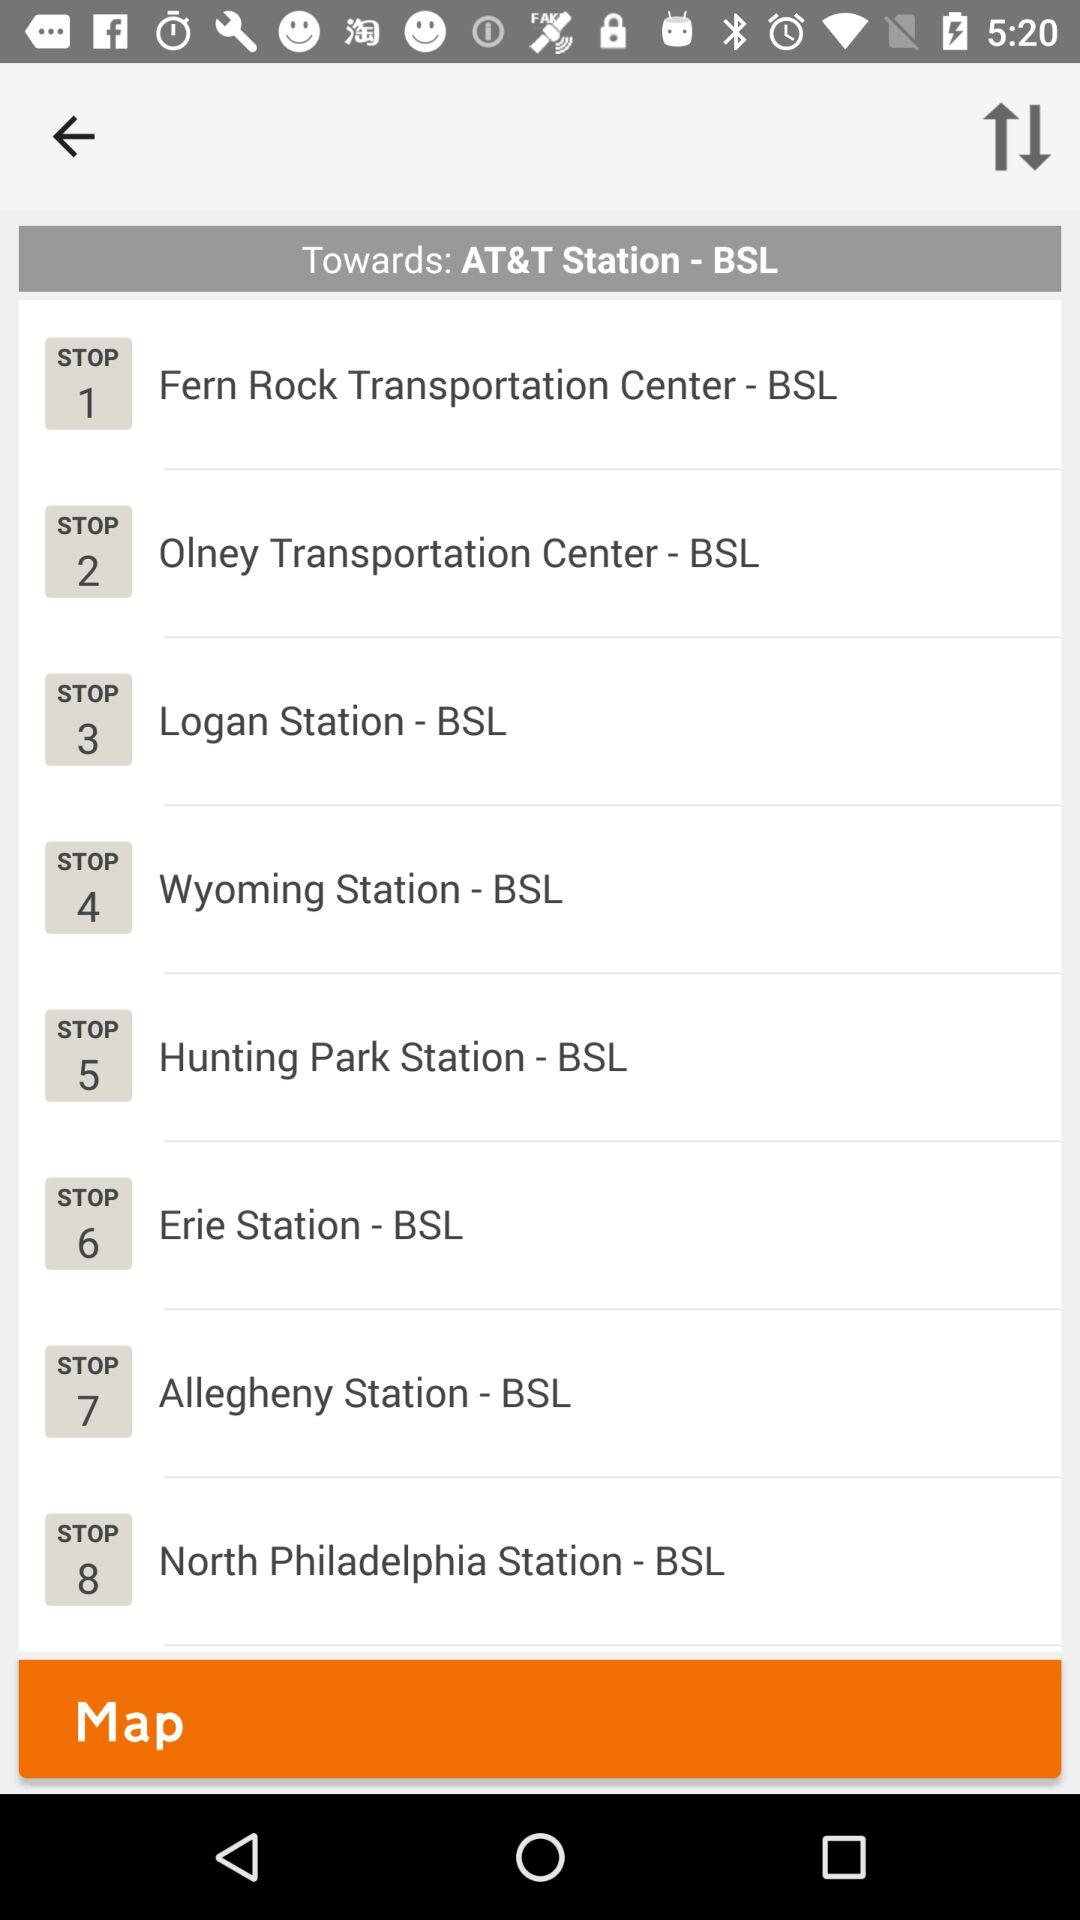What is the stop number for "Logan Station - BSL"? The stop number for "Logan Station - BSL" is 3. 